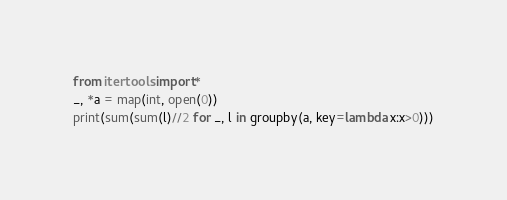<code> <loc_0><loc_0><loc_500><loc_500><_Python_>from itertools import*
_, *a = map(int, open(0))
print(sum(sum(l)//2 for _, l in groupby(a, key=lambda x:x>0)))</code> 